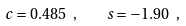<formula> <loc_0><loc_0><loc_500><loc_500>c = 0 . 4 8 5 \ , \quad s = - 1 . 9 0 \ ,</formula> 